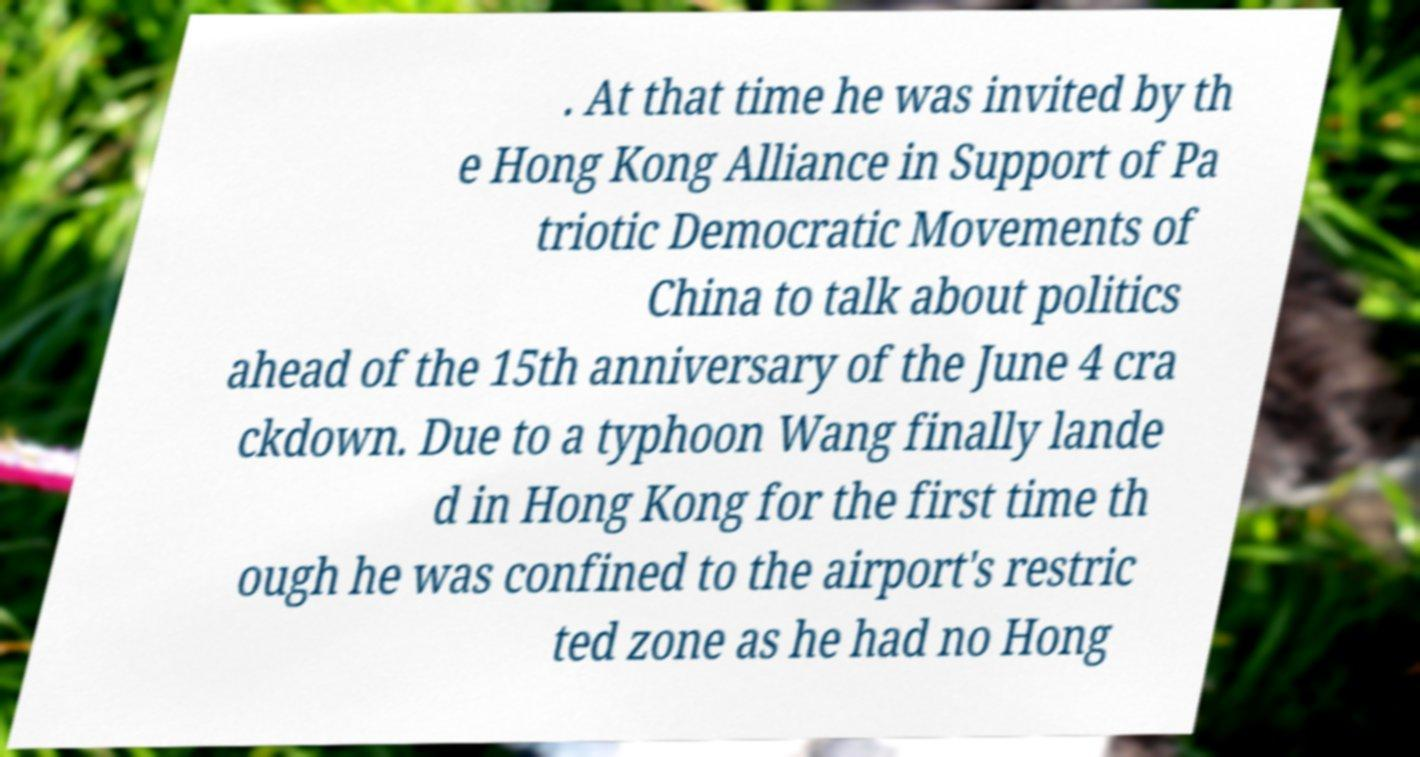I need the written content from this picture converted into text. Can you do that? . At that time he was invited by th e Hong Kong Alliance in Support of Pa triotic Democratic Movements of China to talk about politics ahead of the 15th anniversary of the June 4 cra ckdown. Due to a typhoon Wang finally lande d in Hong Kong for the first time th ough he was confined to the airport's restric ted zone as he had no Hong 